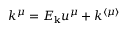<formula> <loc_0><loc_0><loc_500><loc_500>k ^ { \mu } = E _ { k } u ^ { \mu } + k ^ { \langle \mu \rangle }</formula> 